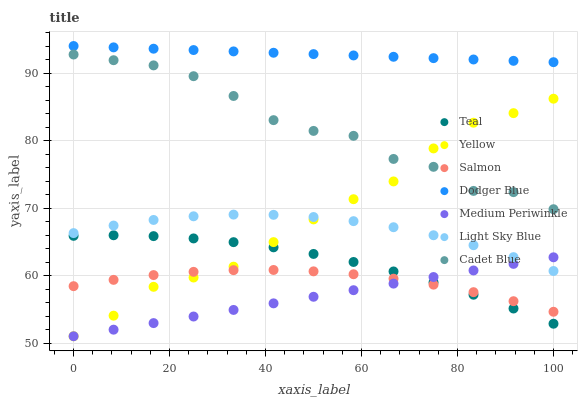Does Medium Periwinkle have the minimum area under the curve?
Answer yes or no. Yes. Does Dodger Blue have the maximum area under the curve?
Answer yes or no. Yes. Does Salmon have the minimum area under the curve?
Answer yes or no. No. Does Salmon have the maximum area under the curve?
Answer yes or no. No. Is Medium Periwinkle the smoothest?
Answer yes or no. Yes. Is Cadet Blue the roughest?
Answer yes or no. Yes. Is Salmon the smoothest?
Answer yes or no. No. Is Salmon the roughest?
Answer yes or no. No. Does Medium Periwinkle have the lowest value?
Answer yes or no. Yes. Does Salmon have the lowest value?
Answer yes or no. No. Does Dodger Blue have the highest value?
Answer yes or no. Yes. Does Medium Periwinkle have the highest value?
Answer yes or no. No. Is Light Sky Blue less than Cadet Blue?
Answer yes or no. Yes. Is Light Sky Blue greater than Teal?
Answer yes or no. Yes. Does Medium Periwinkle intersect Yellow?
Answer yes or no. Yes. Is Medium Periwinkle less than Yellow?
Answer yes or no. No. Is Medium Periwinkle greater than Yellow?
Answer yes or no. No. Does Light Sky Blue intersect Cadet Blue?
Answer yes or no. No. 